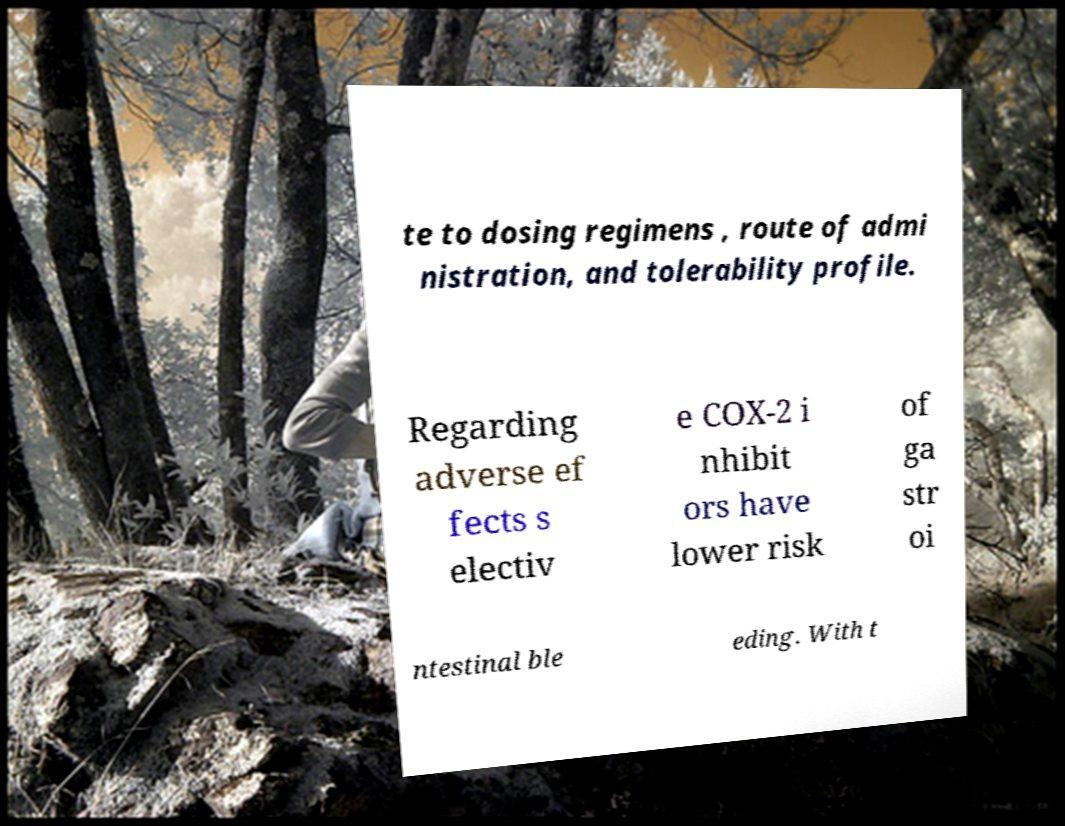Could you extract and type out the text from this image? te to dosing regimens , route of admi nistration, and tolerability profile. Regarding adverse ef fects s electiv e COX-2 i nhibit ors have lower risk of ga str oi ntestinal ble eding. With t 